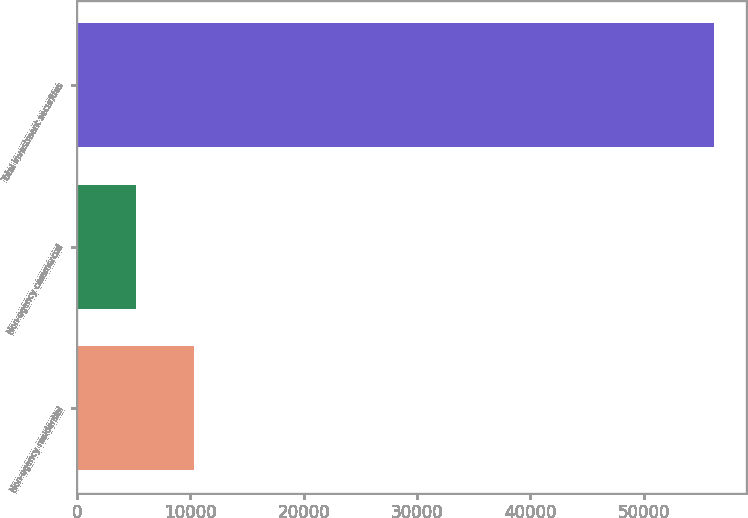<chart> <loc_0><loc_0><loc_500><loc_500><bar_chart><fcel>Non-agency residential<fcel>Non-agency commercial<fcel>Total investment securities<nl><fcel>10293.8<fcel>5191<fcel>56219<nl></chart> 